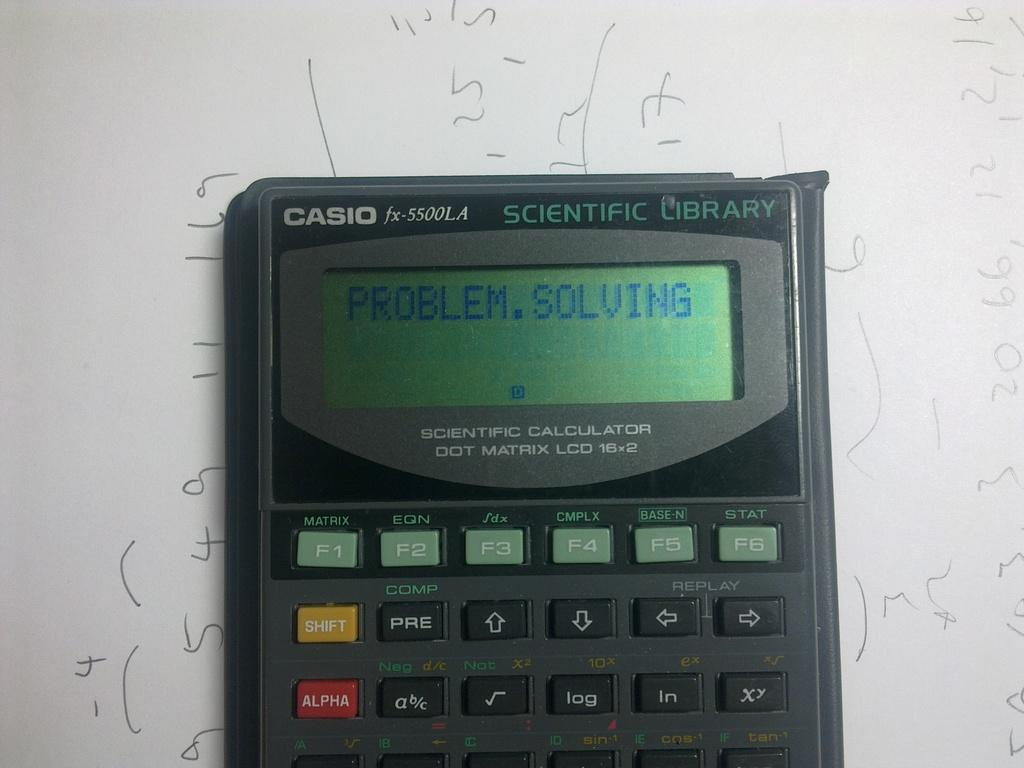What is the main object in the center of the image? There is a calculator in the center of the image. What can be seen in the background of the image? There is text on a board in the background of the image. How many cannons are present in the image? There are no cannons present in the image. What type of adjustment can be seen being made to the line in the image? There is no line or adjustment present in the image. 